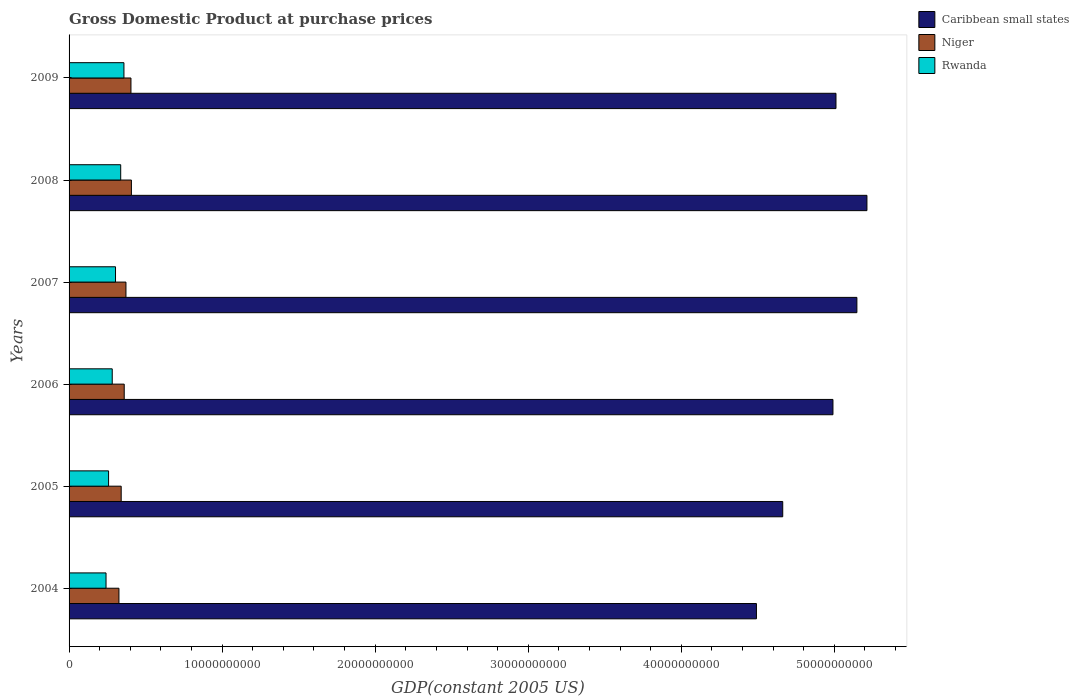How many groups of bars are there?
Provide a succinct answer. 6. Are the number of bars on each tick of the Y-axis equal?
Ensure brevity in your answer.  Yes. How many bars are there on the 1st tick from the top?
Provide a short and direct response. 3. How many bars are there on the 5th tick from the bottom?
Your response must be concise. 3. What is the label of the 3rd group of bars from the top?
Your response must be concise. 2007. In how many cases, is the number of bars for a given year not equal to the number of legend labels?
Offer a terse response. 0. What is the GDP at purchase prices in Niger in 2008?
Make the answer very short. 4.07e+09. Across all years, what is the maximum GDP at purchase prices in Niger?
Make the answer very short. 4.07e+09. Across all years, what is the minimum GDP at purchase prices in Niger?
Provide a short and direct response. 3.26e+09. In which year was the GDP at purchase prices in Rwanda maximum?
Ensure brevity in your answer.  2009. In which year was the GDP at purchase prices in Niger minimum?
Provide a succinct answer. 2004. What is the total GDP at purchase prices in Caribbean small states in the graph?
Provide a short and direct response. 2.95e+11. What is the difference between the GDP at purchase prices in Rwanda in 2004 and that in 2006?
Ensure brevity in your answer.  -4.05e+08. What is the difference between the GDP at purchase prices in Caribbean small states in 2005 and the GDP at purchase prices in Niger in 2008?
Give a very brief answer. 4.26e+1. What is the average GDP at purchase prices in Rwanda per year?
Provide a short and direct response. 2.97e+09. In the year 2008, what is the difference between the GDP at purchase prices in Caribbean small states and GDP at purchase prices in Niger?
Provide a short and direct response. 4.81e+1. What is the ratio of the GDP at purchase prices in Niger in 2004 to that in 2008?
Give a very brief answer. 0.8. Is the difference between the GDP at purchase prices in Caribbean small states in 2004 and 2009 greater than the difference between the GDP at purchase prices in Niger in 2004 and 2009?
Give a very brief answer. No. What is the difference between the highest and the second highest GDP at purchase prices in Niger?
Provide a short and direct response. 2.90e+07. What is the difference between the highest and the lowest GDP at purchase prices in Niger?
Your response must be concise. 8.14e+08. What does the 2nd bar from the top in 2007 represents?
Provide a succinct answer. Niger. What does the 2nd bar from the bottom in 2005 represents?
Provide a short and direct response. Niger. Is it the case that in every year, the sum of the GDP at purchase prices in Caribbean small states and GDP at purchase prices in Rwanda is greater than the GDP at purchase prices in Niger?
Your answer should be compact. Yes. How many bars are there?
Provide a short and direct response. 18. Are all the bars in the graph horizontal?
Your response must be concise. Yes. Are the values on the major ticks of X-axis written in scientific E-notation?
Provide a short and direct response. No. Does the graph contain grids?
Provide a short and direct response. No. How many legend labels are there?
Provide a short and direct response. 3. What is the title of the graph?
Give a very brief answer. Gross Domestic Product at purchase prices. Does "Myanmar" appear as one of the legend labels in the graph?
Your answer should be very brief. No. What is the label or title of the X-axis?
Offer a terse response. GDP(constant 2005 US). What is the label or title of the Y-axis?
Your answer should be very brief. Years. What is the GDP(constant 2005 US) in Caribbean small states in 2004?
Make the answer very short. 4.49e+1. What is the GDP(constant 2005 US) in Niger in 2004?
Your answer should be compact. 3.26e+09. What is the GDP(constant 2005 US) of Rwanda in 2004?
Offer a terse response. 2.41e+09. What is the GDP(constant 2005 US) in Caribbean small states in 2005?
Give a very brief answer. 4.66e+1. What is the GDP(constant 2005 US) of Niger in 2005?
Your answer should be very brief. 3.41e+09. What is the GDP(constant 2005 US) in Rwanda in 2005?
Provide a short and direct response. 2.58e+09. What is the GDP(constant 2005 US) of Caribbean small states in 2006?
Offer a very short reply. 4.99e+1. What is the GDP(constant 2005 US) of Niger in 2006?
Your answer should be very brief. 3.60e+09. What is the GDP(constant 2005 US) of Rwanda in 2006?
Ensure brevity in your answer.  2.82e+09. What is the GDP(constant 2005 US) in Caribbean small states in 2007?
Make the answer very short. 5.15e+1. What is the GDP(constant 2005 US) of Niger in 2007?
Offer a terse response. 3.72e+09. What is the GDP(constant 2005 US) in Rwanda in 2007?
Provide a short and direct response. 3.03e+09. What is the GDP(constant 2005 US) of Caribbean small states in 2008?
Your response must be concise. 5.21e+1. What is the GDP(constant 2005 US) of Niger in 2008?
Offer a terse response. 4.07e+09. What is the GDP(constant 2005 US) in Rwanda in 2008?
Your answer should be compact. 3.37e+09. What is the GDP(constant 2005 US) of Caribbean small states in 2009?
Provide a succinct answer. 5.01e+1. What is the GDP(constant 2005 US) of Niger in 2009?
Your answer should be very brief. 4.04e+09. What is the GDP(constant 2005 US) in Rwanda in 2009?
Keep it short and to the point. 3.58e+09. Across all years, what is the maximum GDP(constant 2005 US) of Caribbean small states?
Your answer should be compact. 5.21e+1. Across all years, what is the maximum GDP(constant 2005 US) in Niger?
Offer a terse response. 4.07e+09. Across all years, what is the maximum GDP(constant 2005 US) of Rwanda?
Give a very brief answer. 3.58e+09. Across all years, what is the minimum GDP(constant 2005 US) in Caribbean small states?
Provide a short and direct response. 4.49e+1. Across all years, what is the minimum GDP(constant 2005 US) in Niger?
Offer a terse response. 3.26e+09. Across all years, what is the minimum GDP(constant 2005 US) in Rwanda?
Give a very brief answer. 2.41e+09. What is the total GDP(constant 2005 US) of Caribbean small states in the graph?
Your answer should be very brief. 2.95e+11. What is the total GDP(constant 2005 US) of Niger in the graph?
Your response must be concise. 2.21e+1. What is the total GDP(constant 2005 US) of Rwanda in the graph?
Provide a succinct answer. 1.78e+1. What is the difference between the GDP(constant 2005 US) of Caribbean small states in 2004 and that in 2005?
Offer a very short reply. -1.72e+09. What is the difference between the GDP(constant 2005 US) of Niger in 2004 and that in 2005?
Your answer should be compact. -1.47e+08. What is the difference between the GDP(constant 2005 US) in Rwanda in 2004 and that in 2005?
Give a very brief answer. -1.67e+08. What is the difference between the GDP(constant 2005 US) in Caribbean small states in 2004 and that in 2006?
Provide a succinct answer. -5.00e+09. What is the difference between the GDP(constant 2005 US) in Niger in 2004 and that in 2006?
Provide a short and direct response. -3.44e+08. What is the difference between the GDP(constant 2005 US) of Rwanda in 2004 and that in 2006?
Ensure brevity in your answer.  -4.05e+08. What is the difference between the GDP(constant 2005 US) of Caribbean small states in 2004 and that in 2007?
Your answer should be compact. -6.56e+09. What is the difference between the GDP(constant 2005 US) in Niger in 2004 and that in 2007?
Give a very brief answer. -4.57e+08. What is the difference between the GDP(constant 2005 US) in Rwanda in 2004 and that in 2007?
Provide a succinct answer. -6.20e+08. What is the difference between the GDP(constant 2005 US) in Caribbean small states in 2004 and that in 2008?
Your response must be concise. -7.22e+09. What is the difference between the GDP(constant 2005 US) of Niger in 2004 and that in 2008?
Your answer should be very brief. -8.14e+08. What is the difference between the GDP(constant 2005 US) in Rwanda in 2004 and that in 2008?
Offer a very short reply. -9.59e+08. What is the difference between the GDP(constant 2005 US) in Caribbean small states in 2004 and that in 2009?
Offer a very short reply. -5.20e+09. What is the difference between the GDP(constant 2005 US) of Niger in 2004 and that in 2009?
Your response must be concise. -7.85e+08. What is the difference between the GDP(constant 2005 US) of Rwanda in 2004 and that in 2009?
Provide a succinct answer. -1.17e+09. What is the difference between the GDP(constant 2005 US) in Caribbean small states in 2005 and that in 2006?
Your answer should be very brief. -3.28e+09. What is the difference between the GDP(constant 2005 US) of Niger in 2005 and that in 2006?
Make the answer very short. -1.97e+08. What is the difference between the GDP(constant 2005 US) of Rwanda in 2005 and that in 2006?
Offer a very short reply. -2.38e+08. What is the difference between the GDP(constant 2005 US) in Caribbean small states in 2005 and that in 2007?
Keep it short and to the point. -4.85e+09. What is the difference between the GDP(constant 2005 US) of Niger in 2005 and that in 2007?
Give a very brief answer. -3.11e+08. What is the difference between the GDP(constant 2005 US) of Rwanda in 2005 and that in 2007?
Keep it short and to the point. -4.53e+08. What is the difference between the GDP(constant 2005 US) of Caribbean small states in 2005 and that in 2008?
Make the answer very short. -5.50e+09. What is the difference between the GDP(constant 2005 US) in Niger in 2005 and that in 2008?
Offer a terse response. -6.67e+08. What is the difference between the GDP(constant 2005 US) of Rwanda in 2005 and that in 2008?
Make the answer very short. -7.92e+08. What is the difference between the GDP(constant 2005 US) of Caribbean small states in 2005 and that in 2009?
Provide a short and direct response. -3.48e+09. What is the difference between the GDP(constant 2005 US) in Niger in 2005 and that in 2009?
Your answer should be compact. -6.38e+08. What is the difference between the GDP(constant 2005 US) of Rwanda in 2005 and that in 2009?
Make the answer very short. -1.00e+09. What is the difference between the GDP(constant 2005 US) of Caribbean small states in 2006 and that in 2007?
Your response must be concise. -1.56e+09. What is the difference between the GDP(constant 2005 US) in Niger in 2006 and that in 2007?
Your response must be concise. -1.13e+08. What is the difference between the GDP(constant 2005 US) of Rwanda in 2006 and that in 2007?
Your answer should be very brief. -2.15e+08. What is the difference between the GDP(constant 2005 US) in Caribbean small states in 2006 and that in 2008?
Your answer should be very brief. -2.22e+09. What is the difference between the GDP(constant 2005 US) of Niger in 2006 and that in 2008?
Offer a terse response. -4.70e+08. What is the difference between the GDP(constant 2005 US) of Rwanda in 2006 and that in 2008?
Provide a succinct answer. -5.53e+08. What is the difference between the GDP(constant 2005 US) in Caribbean small states in 2006 and that in 2009?
Your answer should be very brief. -1.98e+08. What is the difference between the GDP(constant 2005 US) of Niger in 2006 and that in 2009?
Your response must be concise. -4.41e+08. What is the difference between the GDP(constant 2005 US) in Rwanda in 2006 and that in 2009?
Your answer should be very brief. -7.65e+08. What is the difference between the GDP(constant 2005 US) in Caribbean small states in 2007 and that in 2008?
Provide a short and direct response. -6.56e+08. What is the difference between the GDP(constant 2005 US) of Niger in 2007 and that in 2008?
Make the answer very short. -3.56e+08. What is the difference between the GDP(constant 2005 US) of Rwanda in 2007 and that in 2008?
Make the answer very short. -3.39e+08. What is the difference between the GDP(constant 2005 US) in Caribbean small states in 2007 and that in 2009?
Keep it short and to the point. 1.37e+09. What is the difference between the GDP(constant 2005 US) in Niger in 2007 and that in 2009?
Keep it short and to the point. -3.27e+08. What is the difference between the GDP(constant 2005 US) in Rwanda in 2007 and that in 2009?
Provide a succinct answer. -5.50e+08. What is the difference between the GDP(constant 2005 US) in Caribbean small states in 2008 and that in 2009?
Your response must be concise. 2.02e+09. What is the difference between the GDP(constant 2005 US) of Niger in 2008 and that in 2009?
Make the answer very short. 2.90e+07. What is the difference between the GDP(constant 2005 US) in Rwanda in 2008 and that in 2009?
Ensure brevity in your answer.  -2.11e+08. What is the difference between the GDP(constant 2005 US) of Caribbean small states in 2004 and the GDP(constant 2005 US) of Niger in 2005?
Offer a terse response. 4.15e+1. What is the difference between the GDP(constant 2005 US) in Caribbean small states in 2004 and the GDP(constant 2005 US) in Rwanda in 2005?
Your answer should be compact. 4.23e+1. What is the difference between the GDP(constant 2005 US) of Niger in 2004 and the GDP(constant 2005 US) of Rwanda in 2005?
Make the answer very short. 6.77e+08. What is the difference between the GDP(constant 2005 US) in Caribbean small states in 2004 and the GDP(constant 2005 US) in Niger in 2006?
Keep it short and to the point. 4.13e+1. What is the difference between the GDP(constant 2005 US) of Caribbean small states in 2004 and the GDP(constant 2005 US) of Rwanda in 2006?
Your answer should be compact. 4.21e+1. What is the difference between the GDP(constant 2005 US) in Niger in 2004 and the GDP(constant 2005 US) in Rwanda in 2006?
Your answer should be very brief. 4.39e+08. What is the difference between the GDP(constant 2005 US) in Caribbean small states in 2004 and the GDP(constant 2005 US) in Niger in 2007?
Your answer should be very brief. 4.12e+1. What is the difference between the GDP(constant 2005 US) in Caribbean small states in 2004 and the GDP(constant 2005 US) in Rwanda in 2007?
Your answer should be compact. 4.19e+1. What is the difference between the GDP(constant 2005 US) of Niger in 2004 and the GDP(constant 2005 US) of Rwanda in 2007?
Your answer should be very brief. 2.24e+08. What is the difference between the GDP(constant 2005 US) in Caribbean small states in 2004 and the GDP(constant 2005 US) in Niger in 2008?
Provide a short and direct response. 4.08e+1. What is the difference between the GDP(constant 2005 US) in Caribbean small states in 2004 and the GDP(constant 2005 US) in Rwanda in 2008?
Offer a terse response. 4.15e+1. What is the difference between the GDP(constant 2005 US) in Niger in 2004 and the GDP(constant 2005 US) in Rwanda in 2008?
Offer a terse response. -1.15e+08. What is the difference between the GDP(constant 2005 US) of Caribbean small states in 2004 and the GDP(constant 2005 US) of Niger in 2009?
Your answer should be very brief. 4.09e+1. What is the difference between the GDP(constant 2005 US) of Caribbean small states in 2004 and the GDP(constant 2005 US) of Rwanda in 2009?
Make the answer very short. 4.13e+1. What is the difference between the GDP(constant 2005 US) in Niger in 2004 and the GDP(constant 2005 US) in Rwanda in 2009?
Offer a terse response. -3.26e+08. What is the difference between the GDP(constant 2005 US) in Caribbean small states in 2005 and the GDP(constant 2005 US) in Niger in 2006?
Ensure brevity in your answer.  4.30e+1. What is the difference between the GDP(constant 2005 US) of Caribbean small states in 2005 and the GDP(constant 2005 US) of Rwanda in 2006?
Provide a short and direct response. 4.38e+1. What is the difference between the GDP(constant 2005 US) in Niger in 2005 and the GDP(constant 2005 US) in Rwanda in 2006?
Keep it short and to the point. 5.85e+08. What is the difference between the GDP(constant 2005 US) of Caribbean small states in 2005 and the GDP(constant 2005 US) of Niger in 2007?
Give a very brief answer. 4.29e+1. What is the difference between the GDP(constant 2005 US) of Caribbean small states in 2005 and the GDP(constant 2005 US) of Rwanda in 2007?
Offer a terse response. 4.36e+1. What is the difference between the GDP(constant 2005 US) of Niger in 2005 and the GDP(constant 2005 US) of Rwanda in 2007?
Your response must be concise. 3.71e+08. What is the difference between the GDP(constant 2005 US) of Caribbean small states in 2005 and the GDP(constant 2005 US) of Niger in 2008?
Offer a terse response. 4.26e+1. What is the difference between the GDP(constant 2005 US) in Caribbean small states in 2005 and the GDP(constant 2005 US) in Rwanda in 2008?
Offer a terse response. 4.33e+1. What is the difference between the GDP(constant 2005 US) of Niger in 2005 and the GDP(constant 2005 US) of Rwanda in 2008?
Provide a succinct answer. 3.19e+07. What is the difference between the GDP(constant 2005 US) in Caribbean small states in 2005 and the GDP(constant 2005 US) in Niger in 2009?
Keep it short and to the point. 4.26e+1. What is the difference between the GDP(constant 2005 US) in Caribbean small states in 2005 and the GDP(constant 2005 US) in Rwanda in 2009?
Your answer should be compact. 4.30e+1. What is the difference between the GDP(constant 2005 US) of Niger in 2005 and the GDP(constant 2005 US) of Rwanda in 2009?
Your answer should be compact. -1.80e+08. What is the difference between the GDP(constant 2005 US) in Caribbean small states in 2006 and the GDP(constant 2005 US) in Niger in 2007?
Provide a short and direct response. 4.62e+1. What is the difference between the GDP(constant 2005 US) of Caribbean small states in 2006 and the GDP(constant 2005 US) of Rwanda in 2007?
Give a very brief answer. 4.69e+1. What is the difference between the GDP(constant 2005 US) in Niger in 2006 and the GDP(constant 2005 US) in Rwanda in 2007?
Provide a short and direct response. 5.68e+08. What is the difference between the GDP(constant 2005 US) of Caribbean small states in 2006 and the GDP(constant 2005 US) of Niger in 2008?
Your answer should be compact. 4.58e+1. What is the difference between the GDP(constant 2005 US) in Caribbean small states in 2006 and the GDP(constant 2005 US) in Rwanda in 2008?
Your response must be concise. 4.65e+1. What is the difference between the GDP(constant 2005 US) of Niger in 2006 and the GDP(constant 2005 US) of Rwanda in 2008?
Provide a short and direct response. 2.29e+08. What is the difference between the GDP(constant 2005 US) in Caribbean small states in 2006 and the GDP(constant 2005 US) in Niger in 2009?
Provide a succinct answer. 4.59e+1. What is the difference between the GDP(constant 2005 US) of Caribbean small states in 2006 and the GDP(constant 2005 US) of Rwanda in 2009?
Ensure brevity in your answer.  4.63e+1. What is the difference between the GDP(constant 2005 US) in Niger in 2006 and the GDP(constant 2005 US) in Rwanda in 2009?
Your answer should be very brief. 1.79e+07. What is the difference between the GDP(constant 2005 US) in Caribbean small states in 2007 and the GDP(constant 2005 US) in Niger in 2008?
Offer a terse response. 4.74e+1. What is the difference between the GDP(constant 2005 US) in Caribbean small states in 2007 and the GDP(constant 2005 US) in Rwanda in 2008?
Provide a short and direct response. 4.81e+1. What is the difference between the GDP(constant 2005 US) in Niger in 2007 and the GDP(constant 2005 US) in Rwanda in 2008?
Ensure brevity in your answer.  3.43e+08. What is the difference between the GDP(constant 2005 US) in Caribbean small states in 2007 and the GDP(constant 2005 US) in Niger in 2009?
Offer a terse response. 4.74e+1. What is the difference between the GDP(constant 2005 US) of Caribbean small states in 2007 and the GDP(constant 2005 US) of Rwanda in 2009?
Your answer should be compact. 4.79e+1. What is the difference between the GDP(constant 2005 US) in Niger in 2007 and the GDP(constant 2005 US) in Rwanda in 2009?
Provide a short and direct response. 1.31e+08. What is the difference between the GDP(constant 2005 US) of Caribbean small states in 2008 and the GDP(constant 2005 US) of Niger in 2009?
Give a very brief answer. 4.81e+1. What is the difference between the GDP(constant 2005 US) in Caribbean small states in 2008 and the GDP(constant 2005 US) in Rwanda in 2009?
Make the answer very short. 4.85e+1. What is the difference between the GDP(constant 2005 US) in Niger in 2008 and the GDP(constant 2005 US) in Rwanda in 2009?
Your answer should be compact. 4.88e+08. What is the average GDP(constant 2005 US) in Caribbean small states per year?
Make the answer very short. 4.92e+1. What is the average GDP(constant 2005 US) in Niger per year?
Ensure brevity in your answer.  3.68e+09. What is the average GDP(constant 2005 US) of Rwanda per year?
Keep it short and to the point. 2.97e+09. In the year 2004, what is the difference between the GDP(constant 2005 US) in Caribbean small states and GDP(constant 2005 US) in Niger?
Offer a terse response. 4.17e+1. In the year 2004, what is the difference between the GDP(constant 2005 US) of Caribbean small states and GDP(constant 2005 US) of Rwanda?
Give a very brief answer. 4.25e+1. In the year 2004, what is the difference between the GDP(constant 2005 US) in Niger and GDP(constant 2005 US) in Rwanda?
Keep it short and to the point. 8.44e+08. In the year 2005, what is the difference between the GDP(constant 2005 US) of Caribbean small states and GDP(constant 2005 US) of Niger?
Offer a very short reply. 4.32e+1. In the year 2005, what is the difference between the GDP(constant 2005 US) in Caribbean small states and GDP(constant 2005 US) in Rwanda?
Offer a very short reply. 4.40e+1. In the year 2005, what is the difference between the GDP(constant 2005 US) of Niger and GDP(constant 2005 US) of Rwanda?
Keep it short and to the point. 8.24e+08. In the year 2006, what is the difference between the GDP(constant 2005 US) of Caribbean small states and GDP(constant 2005 US) of Niger?
Your response must be concise. 4.63e+1. In the year 2006, what is the difference between the GDP(constant 2005 US) of Caribbean small states and GDP(constant 2005 US) of Rwanda?
Ensure brevity in your answer.  4.71e+1. In the year 2006, what is the difference between the GDP(constant 2005 US) of Niger and GDP(constant 2005 US) of Rwanda?
Give a very brief answer. 7.83e+08. In the year 2007, what is the difference between the GDP(constant 2005 US) of Caribbean small states and GDP(constant 2005 US) of Niger?
Provide a succinct answer. 4.78e+1. In the year 2007, what is the difference between the GDP(constant 2005 US) of Caribbean small states and GDP(constant 2005 US) of Rwanda?
Ensure brevity in your answer.  4.84e+1. In the year 2007, what is the difference between the GDP(constant 2005 US) in Niger and GDP(constant 2005 US) in Rwanda?
Keep it short and to the point. 6.81e+08. In the year 2008, what is the difference between the GDP(constant 2005 US) of Caribbean small states and GDP(constant 2005 US) of Niger?
Your answer should be compact. 4.81e+1. In the year 2008, what is the difference between the GDP(constant 2005 US) of Caribbean small states and GDP(constant 2005 US) of Rwanda?
Offer a very short reply. 4.88e+1. In the year 2008, what is the difference between the GDP(constant 2005 US) in Niger and GDP(constant 2005 US) in Rwanda?
Provide a succinct answer. 6.99e+08. In the year 2009, what is the difference between the GDP(constant 2005 US) in Caribbean small states and GDP(constant 2005 US) in Niger?
Your answer should be compact. 4.61e+1. In the year 2009, what is the difference between the GDP(constant 2005 US) of Caribbean small states and GDP(constant 2005 US) of Rwanda?
Your answer should be very brief. 4.65e+1. In the year 2009, what is the difference between the GDP(constant 2005 US) in Niger and GDP(constant 2005 US) in Rwanda?
Your response must be concise. 4.59e+08. What is the ratio of the GDP(constant 2005 US) in Caribbean small states in 2004 to that in 2005?
Your answer should be compact. 0.96. What is the ratio of the GDP(constant 2005 US) of Niger in 2004 to that in 2005?
Keep it short and to the point. 0.96. What is the ratio of the GDP(constant 2005 US) of Rwanda in 2004 to that in 2005?
Your response must be concise. 0.94. What is the ratio of the GDP(constant 2005 US) in Caribbean small states in 2004 to that in 2006?
Keep it short and to the point. 0.9. What is the ratio of the GDP(constant 2005 US) in Niger in 2004 to that in 2006?
Offer a very short reply. 0.9. What is the ratio of the GDP(constant 2005 US) in Rwanda in 2004 to that in 2006?
Provide a succinct answer. 0.86. What is the ratio of the GDP(constant 2005 US) of Caribbean small states in 2004 to that in 2007?
Provide a short and direct response. 0.87. What is the ratio of the GDP(constant 2005 US) of Niger in 2004 to that in 2007?
Give a very brief answer. 0.88. What is the ratio of the GDP(constant 2005 US) of Rwanda in 2004 to that in 2007?
Make the answer very short. 0.8. What is the ratio of the GDP(constant 2005 US) of Caribbean small states in 2004 to that in 2008?
Ensure brevity in your answer.  0.86. What is the ratio of the GDP(constant 2005 US) of Niger in 2004 to that in 2008?
Keep it short and to the point. 0.8. What is the ratio of the GDP(constant 2005 US) of Rwanda in 2004 to that in 2008?
Provide a succinct answer. 0.72. What is the ratio of the GDP(constant 2005 US) of Caribbean small states in 2004 to that in 2009?
Your answer should be compact. 0.9. What is the ratio of the GDP(constant 2005 US) of Niger in 2004 to that in 2009?
Your answer should be compact. 0.81. What is the ratio of the GDP(constant 2005 US) in Rwanda in 2004 to that in 2009?
Keep it short and to the point. 0.67. What is the ratio of the GDP(constant 2005 US) of Caribbean small states in 2005 to that in 2006?
Provide a short and direct response. 0.93. What is the ratio of the GDP(constant 2005 US) in Niger in 2005 to that in 2006?
Offer a terse response. 0.95. What is the ratio of the GDP(constant 2005 US) of Rwanda in 2005 to that in 2006?
Ensure brevity in your answer.  0.92. What is the ratio of the GDP(constant 2005 US) of Caribbean small states in 2005 to that in 2007?
Keep it short and to the point. 0.91. What is the ratio of the GDP(constant 2005 US) of Niger in 2005 to that in 2007?
Your response must be concise. 0.92. What is the ratio of the GDP(constant 2005 US) in Rwanda in 2005 to that in 2007?
Provide a short and direct response. 0.85. What is the ratio of the GDP(constant 2005 US) in Caribbean small states in 2005 to that in 2008?
Make the answer very short. 0.89. What is the ratio of the GDP(constant 2005 US) in Niger in 2005 to that in 2008?
Give a very brief answer. 0.84. What is the ratio of the GDP(constant 2005 US) of Rwanda in 2005 to that in 2008?
Provide a succinct answer. 0.77. What is the ratio of the GDP(constant 2005 US) of Caribbean small states in 2005 to that in 2009?
Provide a succinct answer. 0.93. What is the ratio of the GDP(constant 2005 US) of Niger in 2005 to that in 2009?
Your response must be concise. 0.84. What is the ratio of the GDP(constant 2005 US) in Rwanda in 2005 to that in 2009?
Give a very brief answer. 0.72. What is the ratio of the GDP(constant 2005 US) of Caribbean small states in 2006 to that in 2007?
Offer a very short reply. 0.97. What is the ratio of the GDP(constant 2005 US) in Niger in 2006 to that in 2007?
Your answer should be very brief. 0.97. What is the ratio of the GDP(constant 2005 US) in Rwanda in 2006 to that in 2007?
Provide a short and direct response. 0.93. What is the ratio of the GDP(constant 2005 US) in Caribbean small states in 2006 to that in 2008?
Make the answer very short. 0.96. What is the ratio of the GDP(constant 2005 US) in Niger in 2006 to that in 2008?
Your answer should be very brief. 0.88. What is the ratio of the GDP(constant 2005 US) of Rwanda in 2006 to that in 2008?
Make the answer very short. 0.84. What is the ratio of the GDP(constant 2005 US) of Caribbean small states in 2006 to that in 2009?
Offer a very short reply. 1. What is the ratio of the GDP(constant 2005 US) in Niger in 2006 to that in 2009?
Offer a very short reply. 0.89. What is the ratio of the GDP(constant 2005 US) of Rwanda in 2006 to that in 2009?
Your answer should be very brief. 0.79. What is the ratio of the GDP(constant 2005 US) in Caribbean small states in 2007 to that in 2008?
Provide a short and direct response. 0.99. What is the ratio of the GDP(constant 2005 US) of Niger in 2007 to that in 2008?
Make the answer very short. 0.91. What is the ratio of the GDP(constant 2005 US) in Rwanda in 2007 to that in 2008?
Give a very brief answer. 0.9. What is the ratio of the GDP(constant 2005 US) of Caribbean small states in 2007 to that in 2009?
Offer a terse response. 1.03. What is the ratio of the GDP(constant 2005 US) of Niger in 2007 to that in 2009?
Give a very brief answer. 0.92. What is the ratio of the GDP(constant 2005 US) of Rwanda in 2007 to that in 2009?
Offer a terse response. 0.85. What is the ratio of the GDP(constant 2005 US) of Caribbean small states in 2008 to that in 2009?
Make the answer very short. 1.04. What is the ratio of the GDP(constant 2005 US) in Rwanda in 2008 to that in 2009?
Provide a short and direct response. 0.94. What is the difference between the highest and the second highest GDP(constant 2005 US) of Caribbean small states?
Your response must be concise. 6.56e+08. What is the difference between the highest and the second highest GDP(constant 2005 US) of Niger?
Offer a terse response. 2.90e+07. What is the difference between the highest and the second highest GDP(constant 2005 US) in Rwanda?
Offer a terse response. 2.11e+08. What is the difference between the highest and the lowest GDP(constant 2005 US) in Caribbean small states?
Provide a short and direct response. 7.22e+09. What is the difference between the highest and the lowest GDP(constant 2005 US) in Niger?
Offer a very short reply. 8.14e+08. What is the difference between the highest and the lowest GDP(constant 2005 US) of Rwanda?
Offer a terse response. 1.17e+09. 